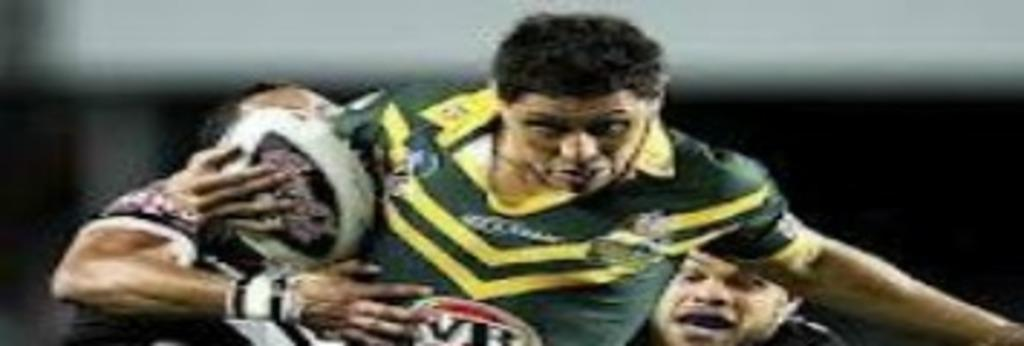How many people are in the image? There are people in the image, but the exact number is not specified. What are the people holding in the image? The people are holding objects in the image. What activity are the people engaged in? The people are playing in the image. What type of nail is being used to sort the current in the image? There is no nail or current present in the image; the people are playing with objects. 